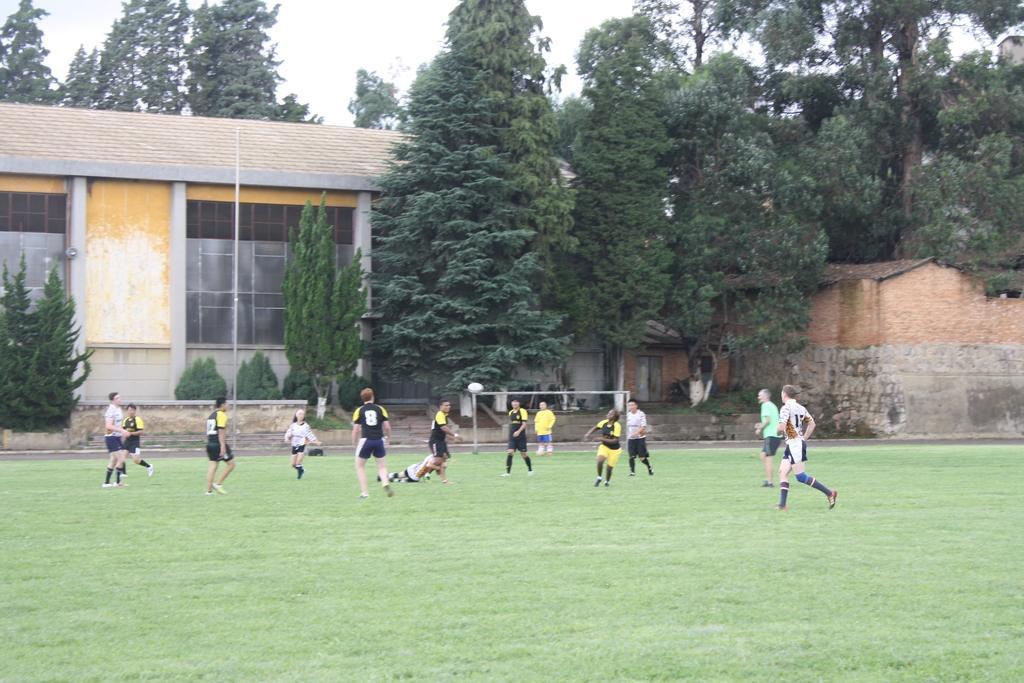Can you describe this image briefly? In this image, there is an outside view. In the foreground, there are some persons wearing clothes and playing a football. In the background, there is a building and some trees. 